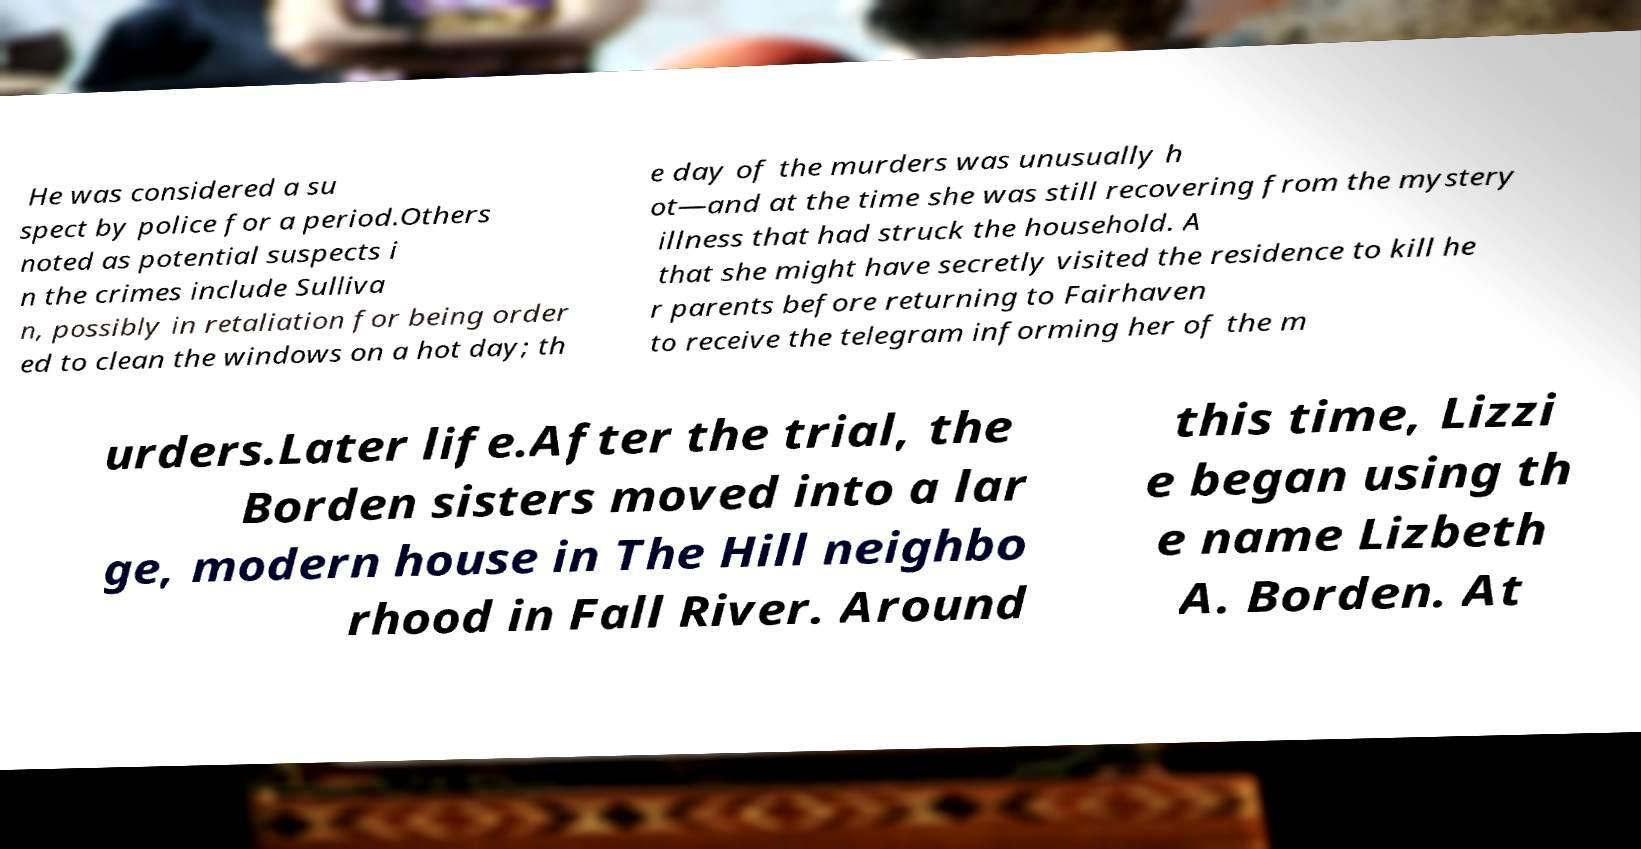Can you read and provide the text displayed in the image?This photo seems to have some interesting text. Can you extract and type it out for me? He was considered a su spect by police for a period.Others noted as potential suspects i n the crimes include Sulliva n, possibly in retaliation for being order ed to clean the windows on a hot day; th e day of the murders was unusually h ot—and at the time she was still recovering from the mystery illness that had struck the household. A that she might have secretly visited the residence to kill he r parents before returning to Fairhaven to receive the telegram informing her of the m urders.Later life.After the trial, the Borden sisters moved into a lar ge, modern house in The Hill neighbo rhood in Fall River. Around this time, Lizzi e began using th e name Lizbeth A. Borden. At 